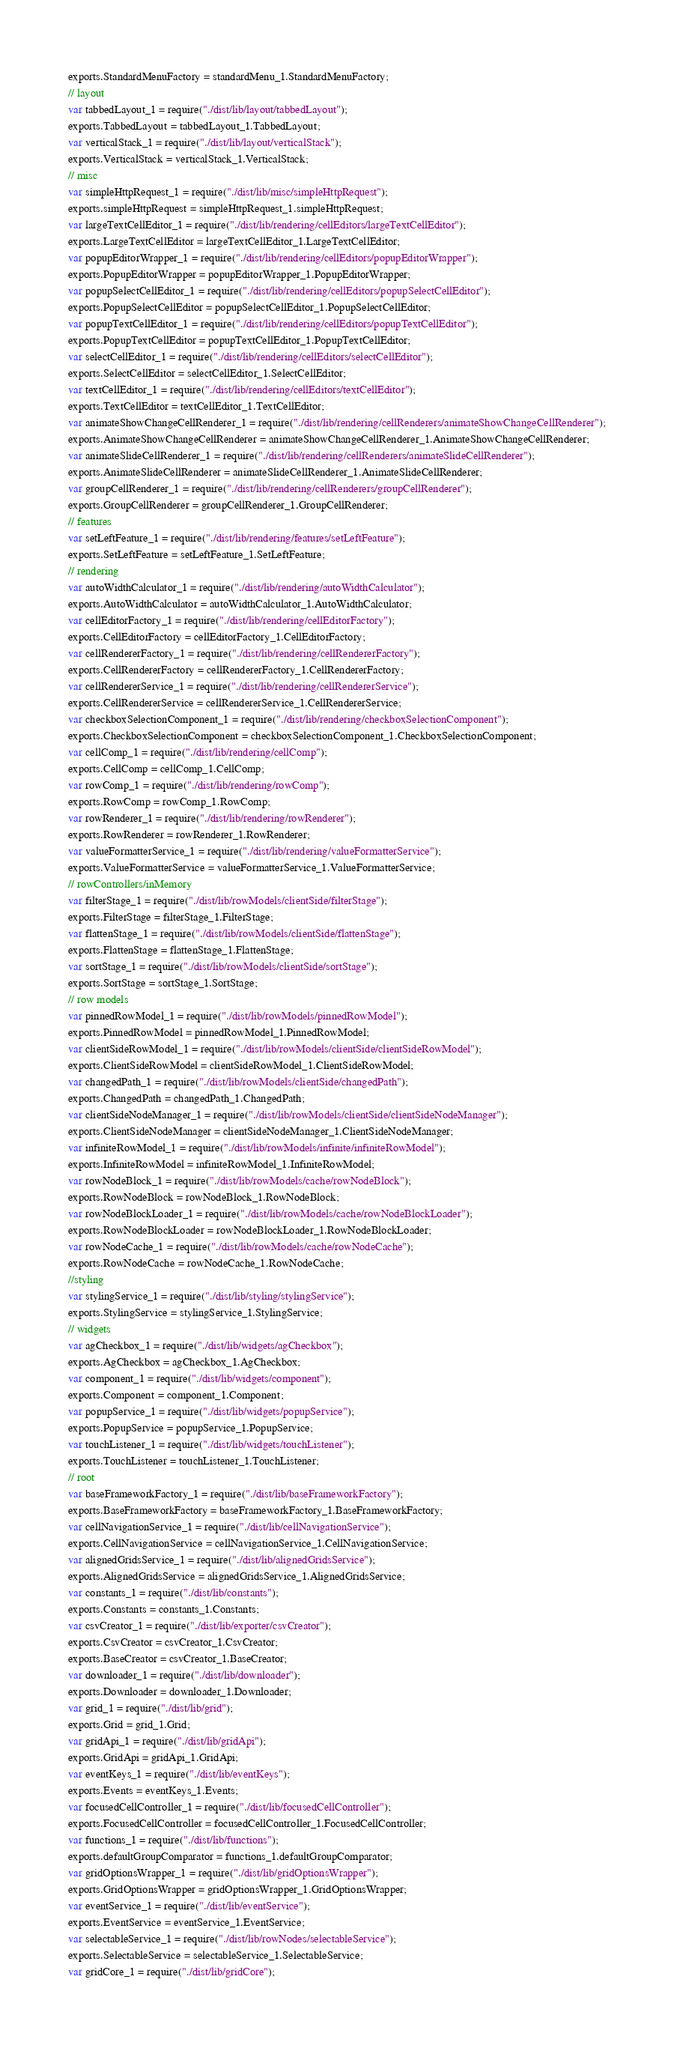<code> <loc_0><loc_0><loc_500><loc_500><_JavaScript_>exports.StandardMenuFactory = standardMenu_1.StandardMenuFactory;
// layout
var tabbedLayout_1 = require("./dist/lib/layout/tabbedLayout");
exports.TabbedLayout = tabbedLayout_1.TabbedLayout;
var verticalStack_1 = require("./dist/lib/layout/verticalStack");
exports.VerticalStack = verticalStack_1.VerticalStack;
// misc
var simpleHttpRequest_1 = require("./dist/lib/misc/simpleHttpRequest");
exports.simpleHttpRequest = simpleHttpRequest_1.simpleHttpRequest;
var largeTextCellEditor_1 = require("./dist/lib/rendering/cellEditors/largeTextCellEditor");
exports.LargeTextCellEditor = largeTextCellEditor_1.LargeTextCellEditor;
var popupEditorWrapper_1 = require("./dist/lib/rendering/cellEditors/popupEditorWrapper");
exports.PopupEditorWrapper = popupEditorWrapper_1.PopupEditorWrapper;
var popupSelectCellEditor_1 = require("./dist/lib/rendering/cellEditors/popupSelectCellEditor");
exports.PopupSelectCellEditor = popupSelectCellEditor_1.PopupSelectCellEditor;
var popupTextCellEditor_1 = require("./dist/lib/rendering/cellEditors/popupTextCellEditor");
exports.PopupTextCellEditor = popupTextCellEditor_1.PopupTextCellEditor;
var selectCellEditor_1 = require("./dist/lib/rendering/cellEditors/selectCellEditor");
exports.SelectCellEditor = selectCellEditor_1.SelectCellEditor;
var textCellEditor_1 = require("./dist/lib/rendering/cellEditors/textCellEditor");
exports.TextCellEditor = textCellEditor_1.TextCellEditor;
var animateShowChangeCellRenderer_1 = require("./dist/lib/rendering/cellRenderers/animateShowChangeCellRenderer");
exports.AnimateShowChangeCellRenderer = animateShowChangeCellRenderer_1.AnimateShowChangeCellRenderer;
var animateSlideCellRenderer_1 = require("./dist/lib/rendering/cellRenderers/animateSlideCellRenderer");
exports.AnimateSlideCellRenderer = animateSlideCellRenderer_1.AnimateSlideCellRenderer;
var groupCellRenderer_1 = require("./dist/lib/rendering/cellRenderers/groupCellRenderer");
exports.GroupCellRenderer = groupCellRenderer_1.GroupCellRenderer;
// features
var setLeftFeature_1 = require("./dist/lib/rendering/features/setLeftFeature");
exports.SetLeftFeature = setLeftFeature_1.SetLeftFeature;
// rendering
var autoWidthCalculator_1 = require("./dist/lib/rendering/autoWidthCalculator");
exports.AutoWidthCalculator = autoWidthCalculator_1.AutoWidthCalculator;
var cellEditorFactory_1 = require("./dist/lib/rendering/cellEditorFactory");
exports.CellEditorFactory = cellEditorFactory_1.CellEditorFactory;
var cellRendererFactory_1 = require("./dist/lib/rendering/cellRendererFactory");
exports.CellRendererFactory = cellRendererFactory_1.CellRendererFactory;
var cellRendererService_1 = require("./dist/lib/rendering/cellRendererService");
exports.CellRendererService = cellRendererService_1.CellRendererService;
var checkboxSelectionComponent_1 = require("./dist/lib/rendering/checkboxSelectionComponent");
exports.CheckboxSelectionComponent = checkboxSelectionComponent_1.CheckboxSelectionComponent;
var cellComp_1 = require("./dist/lib/rendering/cellComp");
exports.CellComp = cellComp_1.CellComp;
var rowComp_1 = require("./dist/lib/rendering/rowComp");
exports.RowComp = rowComp_1.RowComp;
var rowRenderer_1 = require("./dist/lib/rendering/rowRenderer");
exports.RowRenderer = rowRenderer_1.RowRenderer;
var valueFormatterService_1 = require("./dist/lib/rendering/valueFormatterService");
exports.ValueFormatterService = valueFormatterService_1.ValueFormatterService;
// rowControllers/inMemory
var filterStage_1 = require("./dist/lib/rowModels/clientSide/filterStage");
exports.FilterStage = filterStage_1.FilterStage;
var flattenStage_1 = require("./dist/lib/rowModels/clientSide/flattenStage");
exports.FlattenStage = flattenStage_1.FlattenStage;
var sortStage_1 = require("./dist/lib/rowModels/clientSide/sortStage");
exports.SortStage = sortStage_1.SortStage;
// row models
var pinnedRowModel_1 = require("./dist/lib/rowModels/pinnedRowModel");
exports.PinnedRowModel = pinnedRowModel_1.PinnedRowModel;
var clientSideRowModel_1 = require("./dist/lib/rowModels/clientSide/clientSideRowModel");
exports.ClientSideRowModel = clientSideRowModel_1.ClientSideRowModel;
var changedPath_1 = require("./dist/lib/rowModels/clientSide/changedPath");
exports.ChangedPath = changedPath_1.ChangedPath;
var clientSideNodeManager_1 = require("./dist/lib/rowModels/clientSide/clientSideNodeManager");
exports.ClientSideNodeManager = clientSideNodeManager_1.ClientSideNodeManager;
var infiniteRowModel_1 = require("./dist/lib/rowModels/infinite/infiniteRowModel");
exports.InfiniteRowModel = infiniteRowModel_1.InfiniteRowModel;
var rowNodeBlock_1 = require("./dist/lib/rowModels/cache/rowNodeBlock");
exports.RowNodeBlock = rowNodeBlock_1.RowNodeBlock;
var rowNodeBlockLoader_1 = require("./dist/lib/rowModels/cache/rowNodeBlockLoader");
exports.RowNodeBlockLoader = rowNodeBlockLoader_1.RowNodeBlockLoader;
var rowNodeCache_1 = require("./dist/lib/rowModels/cache/rowNodeCache");
exports.RowNodeCache = rowNodeCache_1.RowNodeCache;
//styling
var stylingService_1 = require("./dist/lib/styling/stylingService");
exports.StylingService = stylingService_1.StylingService;
// widgets
var agCheckbox_1 = require("./dist/lib/widgets/agCheckbox");
exports.AgCheckbox = agCheckbox_1.AgCheckbox;
var component_1 = require("./dist/lib/widgets/component");
exports.Component = component_1.Component;
var popupService_1 = require("./dist/lib/widgets/popupService");
exports.PopupService = popupService_1.PopupService;
var touchListener_1 = require("./dist/lib/widgets/touchListener");
exports.TouchListener = touchListener_1.TouchListener;
// root
var baseFrameworkFactory_1 = require("./dist/lib/baseFrameworkFactory");
exports.BaseFrameworkFactory = baseFrameworkFactory_1.BaseFrameworkFactory;
var cellNavigationService_1 = require("./dist/lib/cellNavigationService");
exports.CellNavigationService = cellNavigationService_1.CellNavigationService;
var alignedGridsService_1 = require("./dist/lib/alignedGridsService");
exports.AlignedGridsService = alignedGridsService_1.AlignedGridsService;
var constants_1 = require("./dist/lib/constants");
exports.Constants = constants_1.Constants;
var csvCreator_1 = require("./dist/lib/exporter/csvCreator");
exports.CsvCreator = csvCreator_1.CsvCreator;
exports.BaseCreator = csvCreator_1.BaseCreator;
var downloader_1 = require("./dist/lib/downloader");
exports.Downloader = downloader_1.Downloader;
var grid_1 = require("./dist/lib/grid");
exports.Grid = grid_1.Grid;
var gridApi_1 = require("./dist/lib/gridApi");
exports.GridApi = gridApi_1.GridApi;
var eventKeys_1 = require("./dist/lib/eventKeys");
exports.Events = eventKeys_1.Events;
var focusedCellController_1 = require("./dist/lib/focusedCellController");
exports.FocusedCellController = focusedCellController_1.FocusedCellController;
var functions_1 = require("./dist/lib/functions");
exports.defaultGroupComparator = functions_1.defaultGroupComparator;
var gridOptionsWrapper_1 = require("./dist/lib/gridOptionsWrapper");
exports.GridOptionsWrapper = gridOptionsWrapper_1.GridOptionsWrapper;
var eventService_1 = require("./dist/lib/eventService");
exports.EventService = eventService_1.EventService;
var selectableService_1 = require("./dist/lib/rowNodes/selectableService");
exports.SelectableService = selectableService_1.SelectableService;
var gridCore_1 = require("./dist/lib/gridCore");</code> 